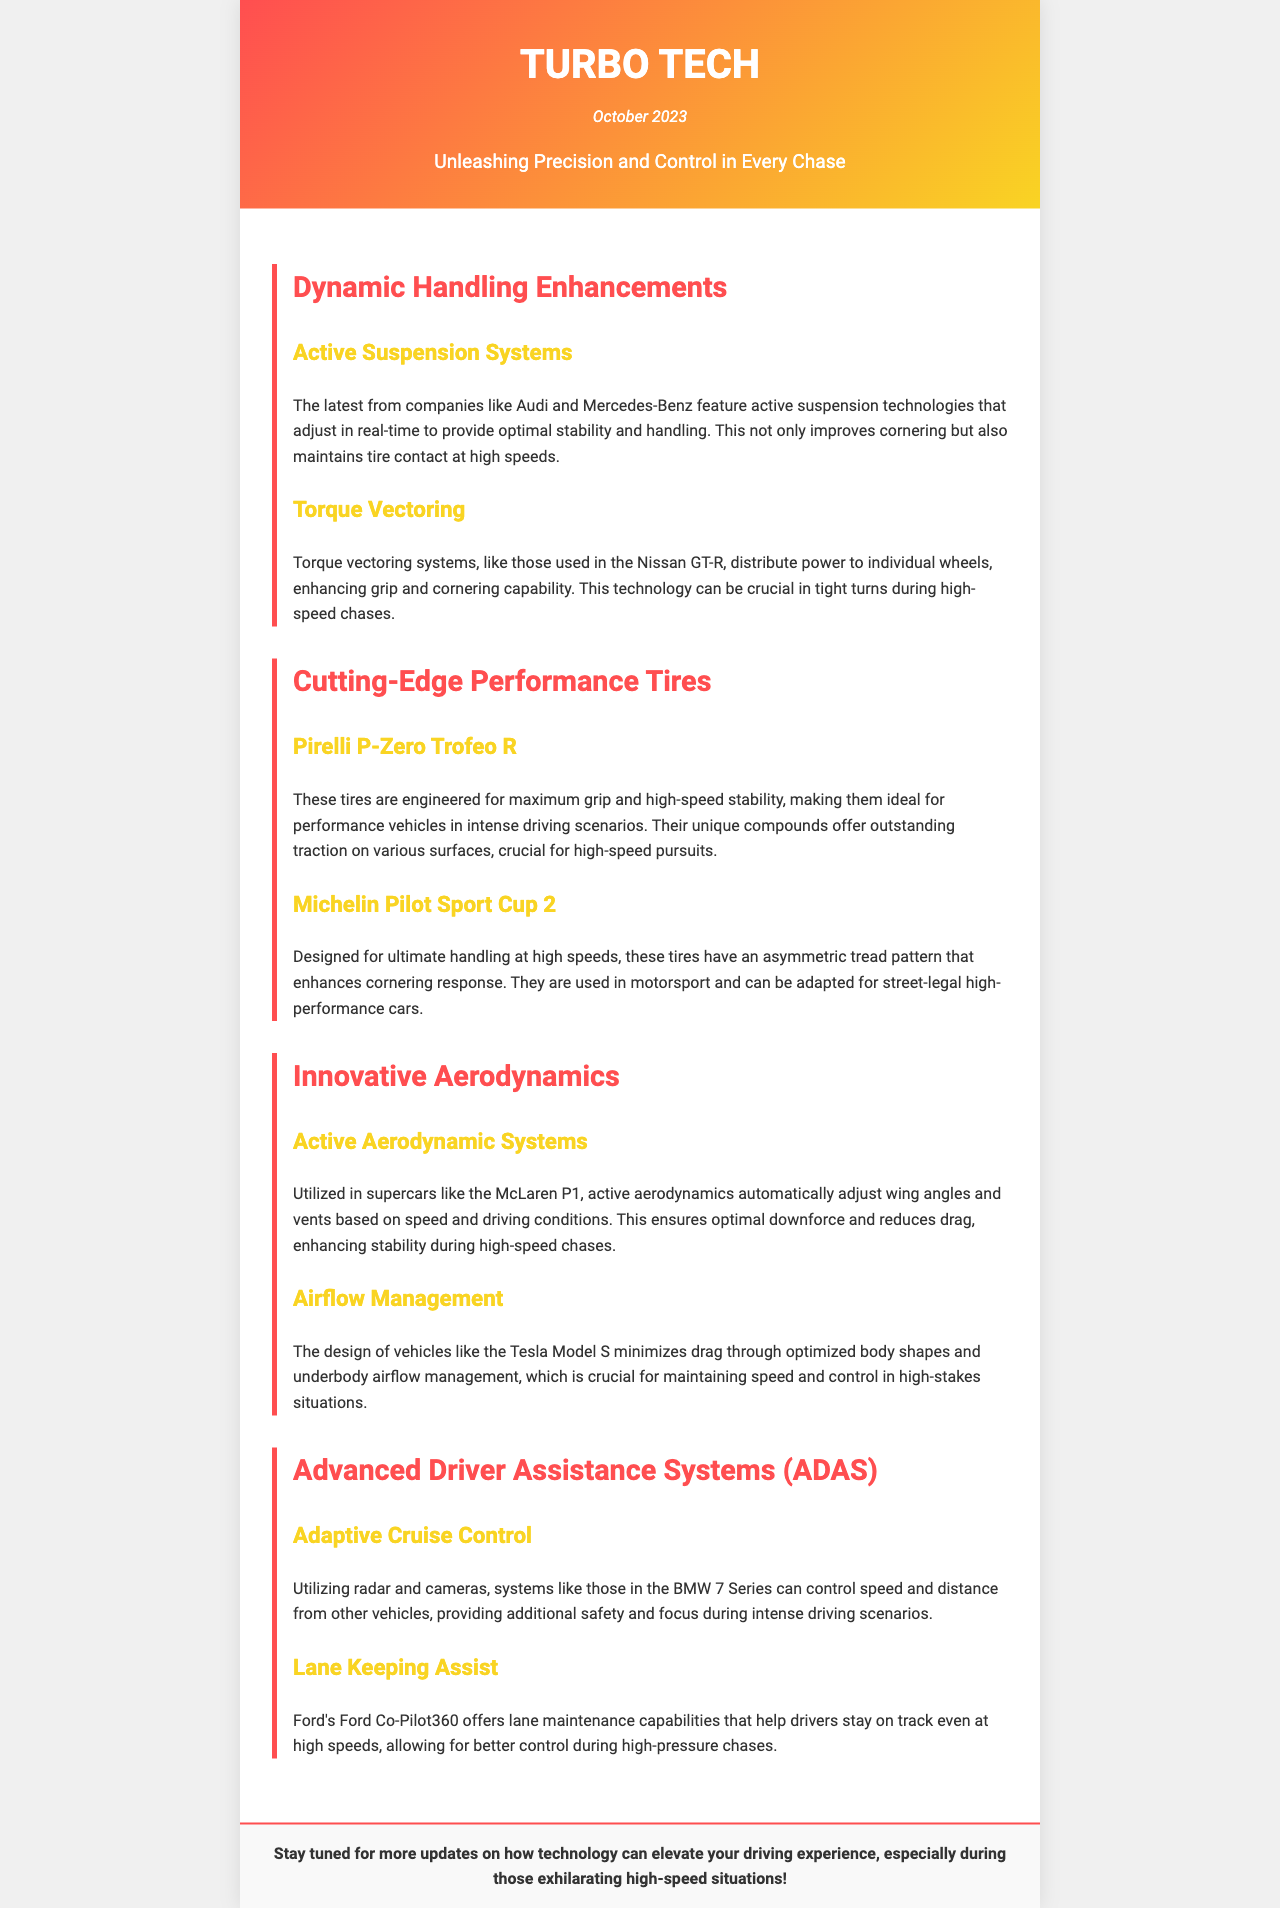what is the title of the newsletter? The title of the newsletter is displayed prominently at the top, indicating its theme on automotive technology for high-speed pursuits.
Answer: Turbo Tech what month and year was the newsletter published? The publication date is mentioned right below the title, offering the specific month and year.
Answer: October 2023 which company features active suspension technologies? The document lists companies contributing to advancements in active suspension technologies, providing specific examples.
Answer: Audi and Mercedes-Benz what type of tires are highlighted for maximum grip? The document discusses specific tires designed for optimal performance in high-speed driving situations.
Answer: Pirelli P-Zero Trofeo R what is one of the functionalities of Adaptive Cruise Control? This system's capability is explained in relation to its use for improving safety and focus during intense situations.
Answer: Control speed and distance which vehicle uses active aerodynamic systems? The document provides examples of supercars that utilize advanced aerodynamic technologies for stability.
Answer: McLaren P1 how does torque vectoring enhance vehicle handling? The explanation in the document clarifies how torque vectoring distributes power for improved cornering.
Answer: Enhances grip and cornering capability what is mentioned as a feature of Michelin Pilot Sport Cup 2 tires? The document describes attributes that make these tires suitable for high-speed performance.
Answer: Asymmetric tread pattern what type of systems does Ford's Co-Pilot360 offer? The specific system associated with Ford is detailed, emphasizing its function in driver assistance.
Answer: Lane Keeping Assist 